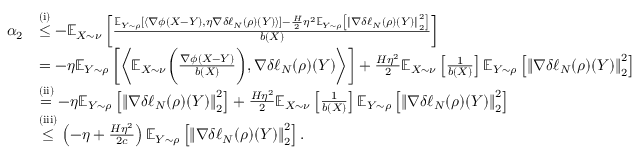Convert formula to latex. <formula><loc_0><loc_0><loc_500><loc_500>\begin{array} { r l } { \alpha _ { 2 } } & { \overset { ( i ) } { \leq } - \mathbb { E } _ { X \sim \nu } \left [ \frac { \mathbb { E } _ { Y \sim \rho } \left [ \left \langle \nabla \phi ( X - Y ) , \eta \nabla \delta \ell _ { N } ( \rho ) ( Y ) \right \rangle \right ] - \frac { H } { 2 } \eta ^ { 2 } \mathbb { E } _ { Y \sim \rho } \left [ \left \| \nabla \delta \ell _ { N } ( \rho ) ( Y ) \right \| _ { 2 } ^ { 2 } \right ] } { b \left ( X \right ) } \right ] } \\ & { = - \eta \mathbb { E } _ { Y \sim \rho } \left [ \left \langle \mathbb { E } _ { X \sim \nu } \left ( \frac { \nabla \phi ( X - Y ) } { b ( X ) } \right ) , \nabla \delta \ell _ { N } ( \rho ) ( Y ) \right \rangle \right ] + \frac { H \eta ^ { 2 } } { 2 } \mathbb { E } _ { X \sim \nu } \left [ \frac { 1 } { b ( X ) } \right ] \mathbb { E } _ { Y \sim \rho } \left [ \left \| \nabla \delta \ell _ { N } ( \rho ) ( Y ) \right \| _ { 2 } ^ { 2 } \right ] } \\ & { \overset { ( i i ) } { = } - \eta \mathbb { E } _ { Y \sim \rho } \left [ \left \| \nabla \delta \ell _ { N } ( \rho ) ( Y ) \right \| _ { 2 } ^ { 2 } \right ] + \frac { H \eta ^ { 2 } } { 2 } \mathbb { E } _ { X \sim \nu } \left [ \frac { 1 } { b ( X ) } \right ] \mathbb { E } _ { Y \sim \rho } \left [ \left \| \nabla \delta \ell _ { N } ( \rho ) ( Y ) \right \| _ { 2 } ^ { 2 } \right ] } \\ & { \overset { ( i i i ) } { \leq } \left ( - \eta + \frac { H \eta ^ { 2 } } { 2 c } \right ) \mathbb { E } _ { Y \sim \rho } \left [ \left \| \nabla \delta \ell _ { N } ( \rho ) ( Y ) \right \| _ { 2 } ^ { 2 } \right ] . } \end{array}</formula> 